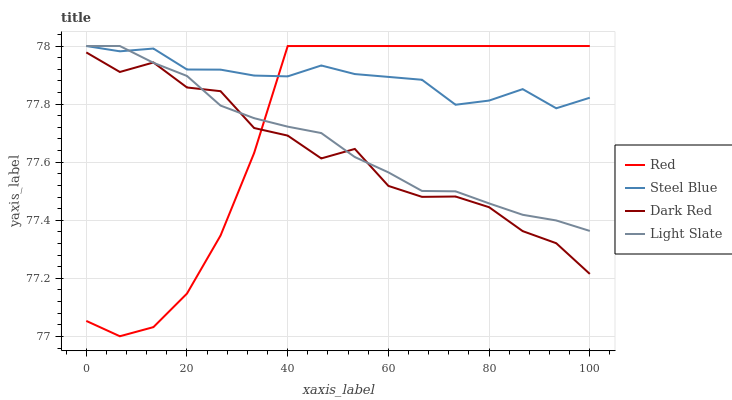Does Dark Red have the minimum area under the curve?
Answer yes or no. Yes. Does Steel Blue have the maximum area under the curve?
Answer yes or no. Yes. Does Steel Blue have the minimum area under the curve?
Answer yes or no. No. Does Dark Red have the maximum area under the curve?
Answer yes or no. No. Is Light Slate the smoothest?
Answer yes or no. Yes. Is Dark Red the roughest?
Answer yes or no. Yes. Is Steel Blue the smoothest?
Answer yes or no. No. Is Steel Blue the roughest?
Answer yes or no. No. Does Red have the lowest value?
Answer yes or no. Yes. Does Dark Red have the lowest value?
Answer yes or no. No. Does Red have the highest value?
Answer yes or no. Yes. Does Dark Red have the highest value?
Answer yes or no. No. Is Dark Red less than Steel Blue?
Answer yes or no. Yes. Is Steel Blue greater than Dark Red?
Answer yes or no. Yes. Does Red intersect Light Slate?
Answer yes or no. Yes. Is Red less than Light Slate?
Answer yes or no. No. Is Red greater than Light Slate?
Answer yes or no. No. Does Dark Red intersect Steel Blue?
Answer yes or no. No. 